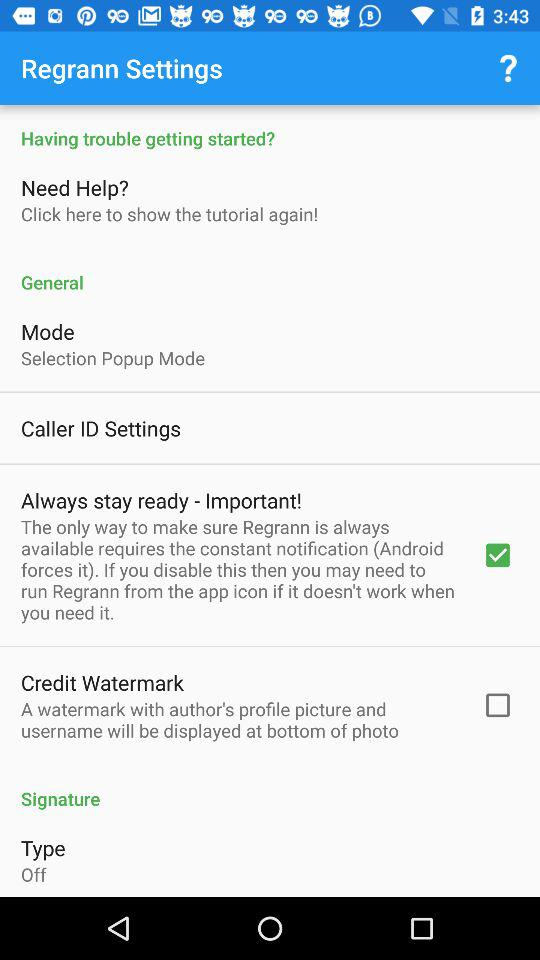What is the name of the application? The name of the application is "Regrann". 